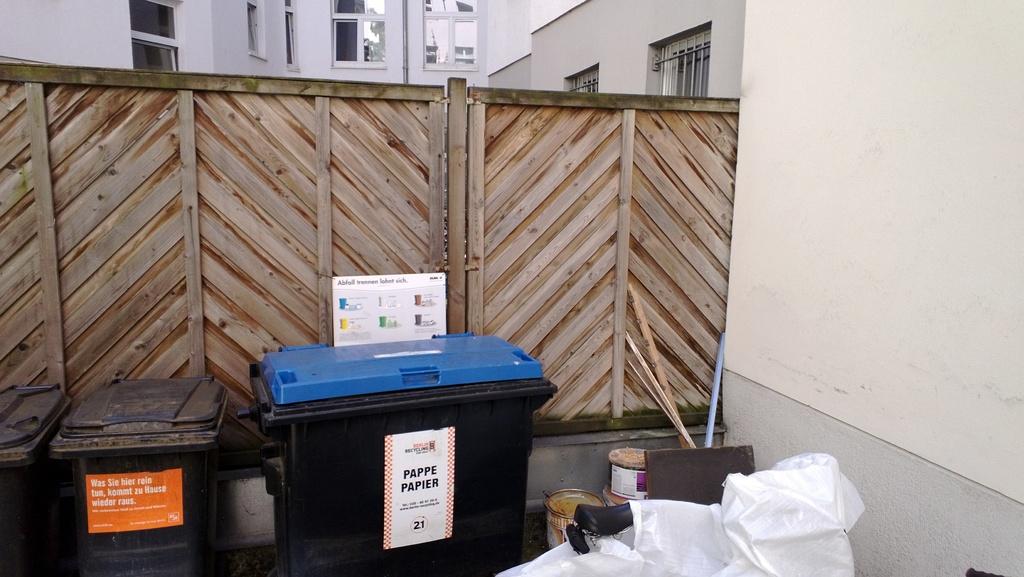What is that bin on the right?
Your answer should be compact. Paper. Which recycling bin does paper go in?
Make the answer very short. Blue. 